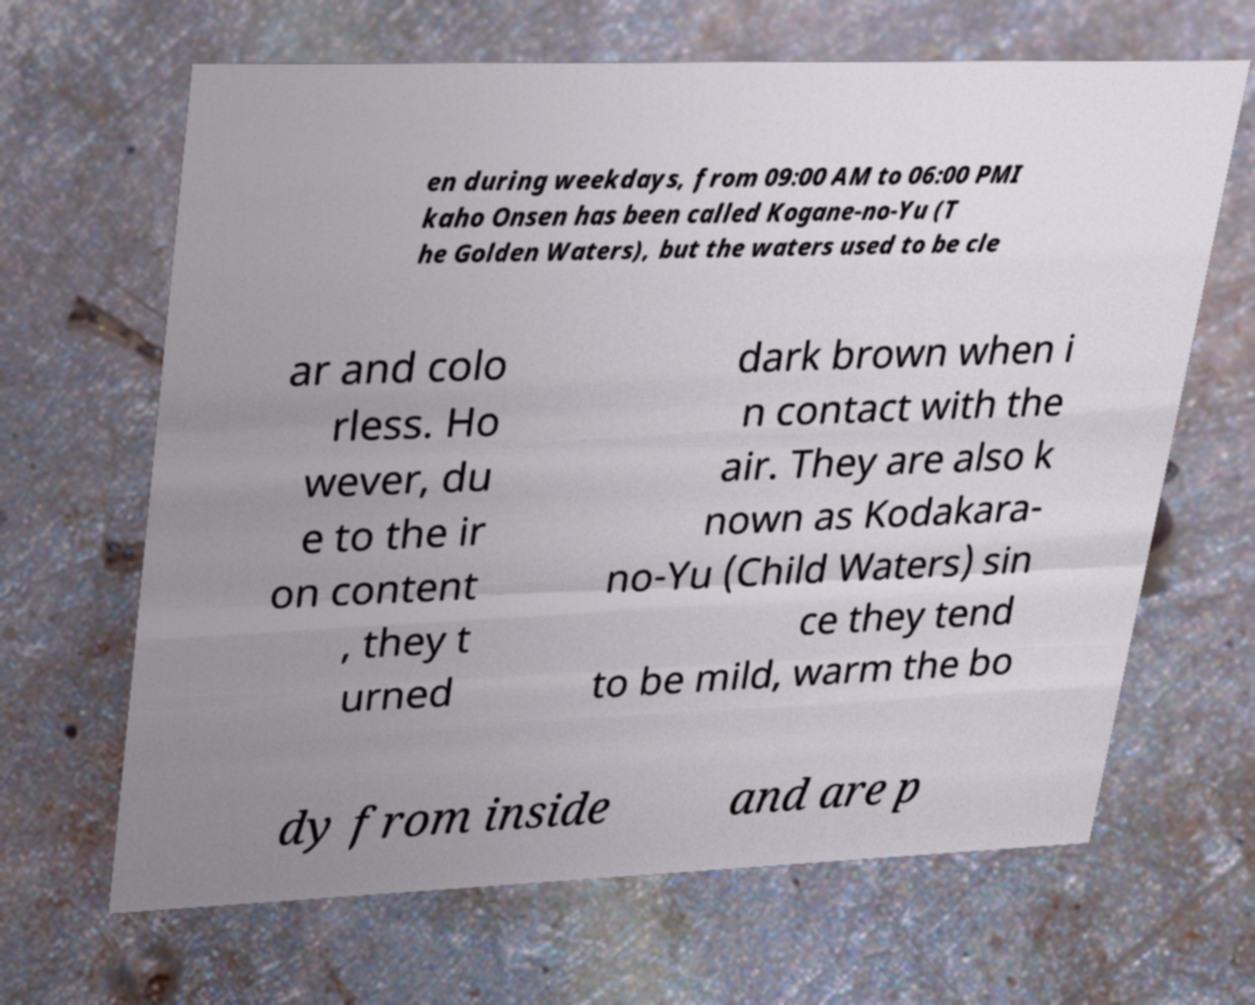I need the written content from this picture converted into text. Can you do that? en during weekdays, from 09:00 AM to 06:00 PMI kaho Onsen has been called Kogane-no-Yu (T he Golden Waters), but the waters used to be cle ar and colo rless. Ho wever, du e to the ir on content , they t urned dark brown when i n contact with the air. They are also k nown as Kodakara- no-Yu (Child Waters) sin ce they tend to be mild, warm the bo dy from inside and are p 